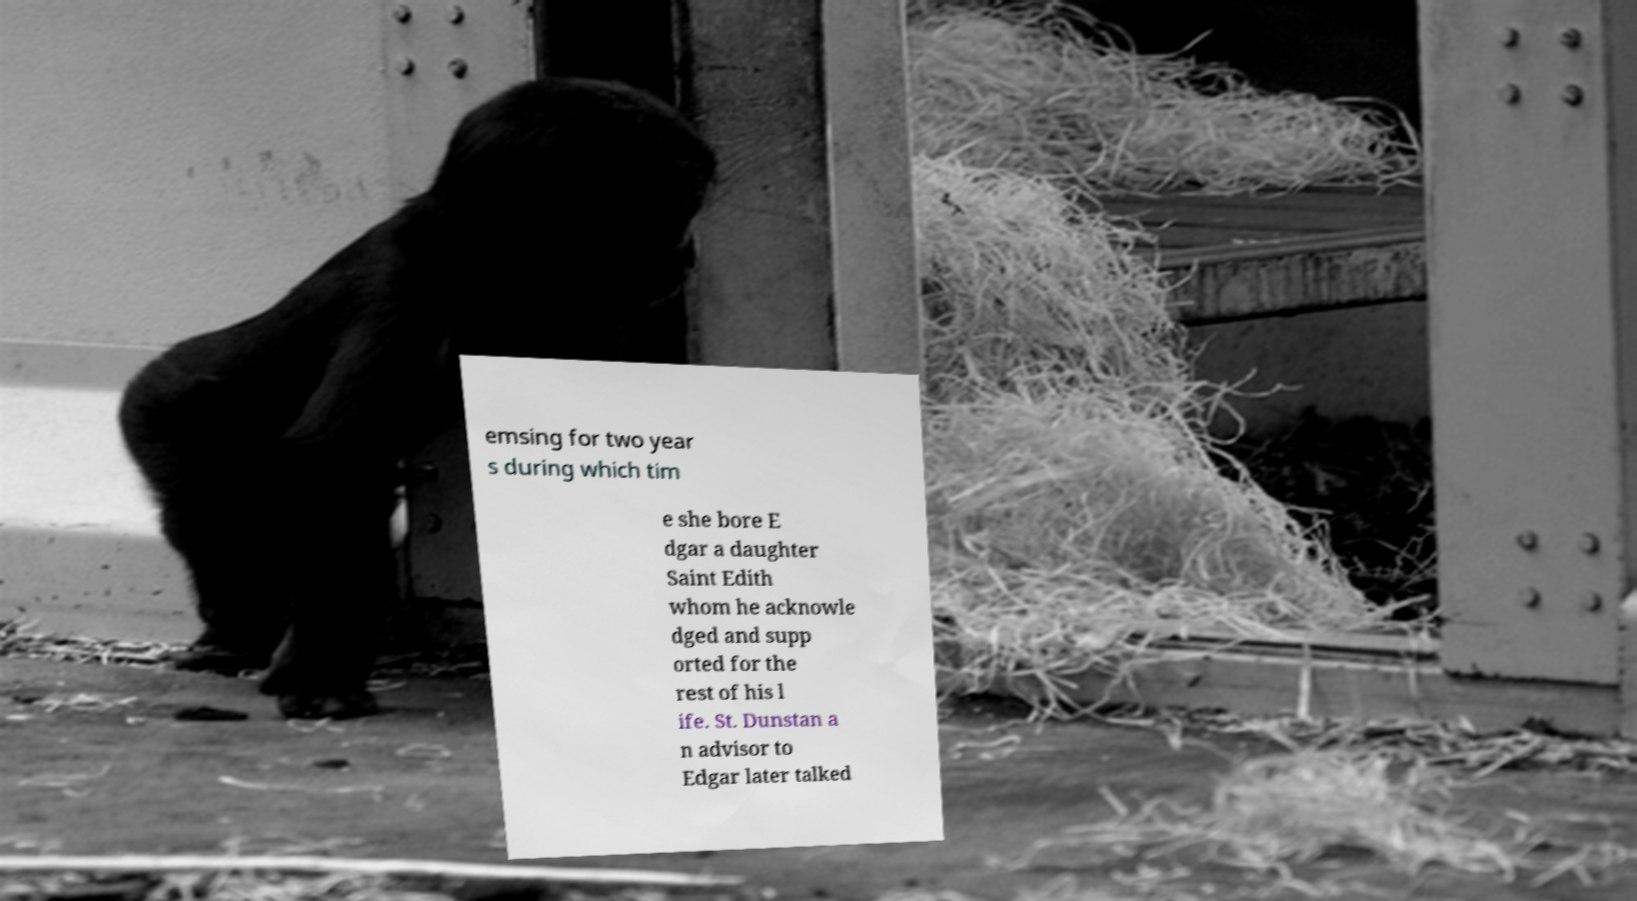There's text embedded in this image that I need extracted. Can you transcribe it verbatim? emsing for two year s during which tim e she bore E dgar a daughter Saint Edith whom he acknowle dged and supp orted for the rest of his l ife. St. Dunstan a n advisor to Edgar later talked 